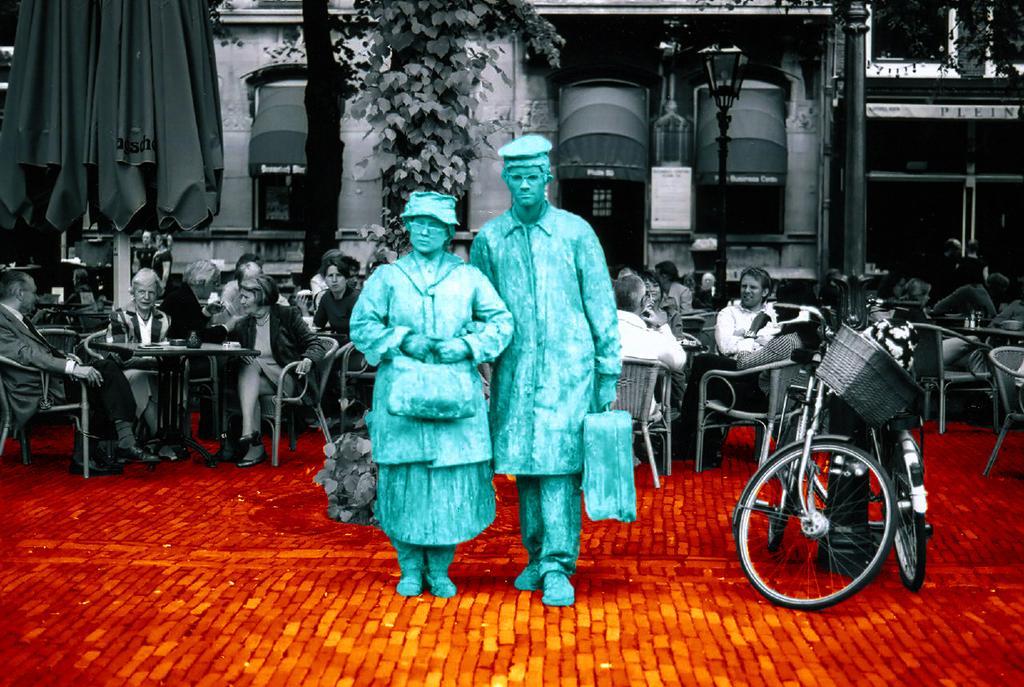How would you summarize this image in a sentence or two? In this picture there are two blue color statue of man and woman, standing on the cobbler stones. Behind there is a open restaurant and a group of men and women sitting on the chairs and discussing something. In the background we can see a restaurant windows and some trees. On the right side there is a black color gate. 